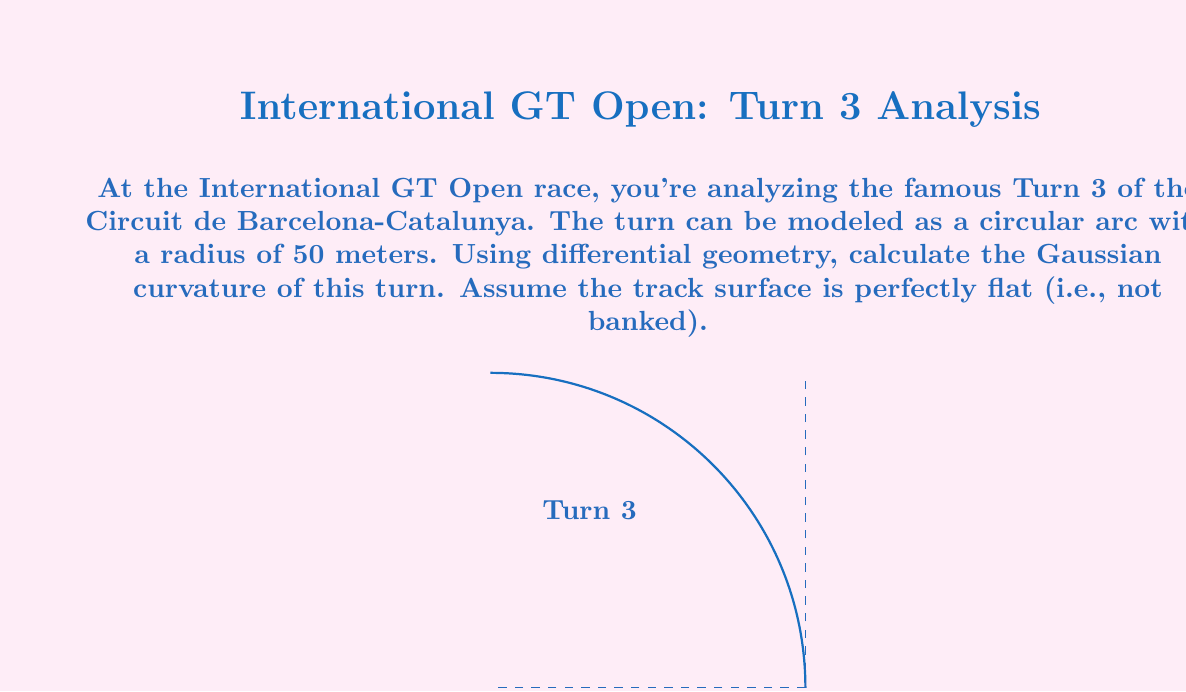What is the answer to this math problem? Let's approach this step-by-step:

1) In differential geometry, the Gaussian curvature (K) of a surface at a point is the product of its two principal curvatures at that point.

2) For a flat surface (like our racetrack), one of the principal curvatures is always zero. Let's call this $k_1 = 0$.

3) The other principal curvature ($k_2$) is the curvature of the path on the surface. For a circular arc, this is the reciprocal of the radius:

   $k_2 = \frac{1}{r}$

   where $r$ is the radius of the circle.

4) Given that the radius of Turn 3 is 50 meters:

   $k_2 = \frac{1}{50} = 0.02$ m^(-1)

5) The Gaussian curvature is then:

   $K = k_1 \cdot k_2 = 0 \cdot 0.02 = 0$

6) This result makes sense geometrically. A flat surface that's curved in only one direction (like a cylinder) has zero Gaussian curvature at all points.
Answer: $K = 0$ m^(-2) 